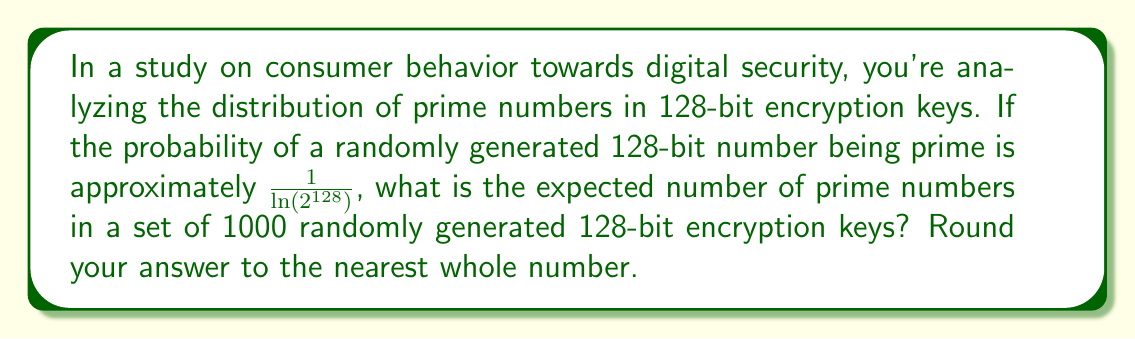Provide a solution to this math problem. Let's approach this step-by-step:

1) First, we need to calculate the probability of a 128-bit number being prime.
   The probability is given as $\frac{1}{\ln(2^{128})}$

2) Let's calculate $\ln(2^{128})$:
   $\ln(2^{128}) = 128 \times \ln(2) \approx 88.72$

3) So, the probability of a 128-bit number being prime is:
   $P(\text{prime}) = \frac{1}{88.72} \approx 0.01127$

4) Now, we're dealing with 1000 randomly generated keys. This scenario follows a binomial distribution, where we're interested in the expected number of successes (primes) in 1000 trials.

5) For a binomial distribution, the expected value is given by $n \times p$, where:
   $n$ = number of trials (1000 in this case)
   $p$ = probability of success on each trial (0.01127 in this case)

6) Therefore, the expected number of primes is:
   $E(\text{primes}) = 1000 \times 0.01127 = 11.27$

7) Rounding to the nearest whole number, we get 11.
Answer: 11 